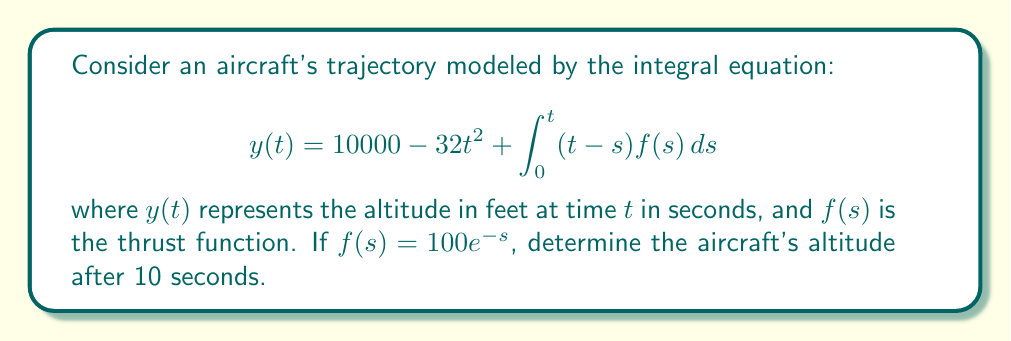Can you solve this math problem? Let's solve this step-by-step:

1) We need to evaluate $y(10)$ using the given equation:

   $$y(10) = 10000 - 32(10)^2 + \int_0^{10} (10-s)f(s)ds$$

2) First, calculate the second term:
   
   $32(10)^2 = 32 \times 100 = 3200$

3) Now, let's focus on the integral:

   $$\int_0^{10} (10-s)f(s)ds = \int_0^{10} (10-s)(100e^{-s})ds$$

4) To solve this integral, we can use integration by parts. Let:
   
   $u = 10-s$, $du = -ds$
   $dv = 100e^{-s}ds$, $v = -100e^{-s}$

5) Applying integration by parts formula:

   $$\int_0^{10} (10-s)(100e^{-s})ds = [(10-s)(-100e^{-s})]_0^{10} + \int_0^{10} 100e^{-s}ds$$

6) Evaluate the first part:

   $[(10-s)(-100e^{-s})]_0^{10} = [0 - (-1000)] = 1000$

7) Solve the remaining integral:

   $$\int_0^{10} 100e^{-s}ds = [-100e^{-s}]_0^{10} = -100e^{-10} + 100 \approx 100$$

8) Sum up the results from steps 6 and 7:

   $1000 + 100 = 1100$

9) Now, we can put all parts together:

   $y(10) = 10000 - 3200 + 1100 = 7900$
Answer: 7900 feet 